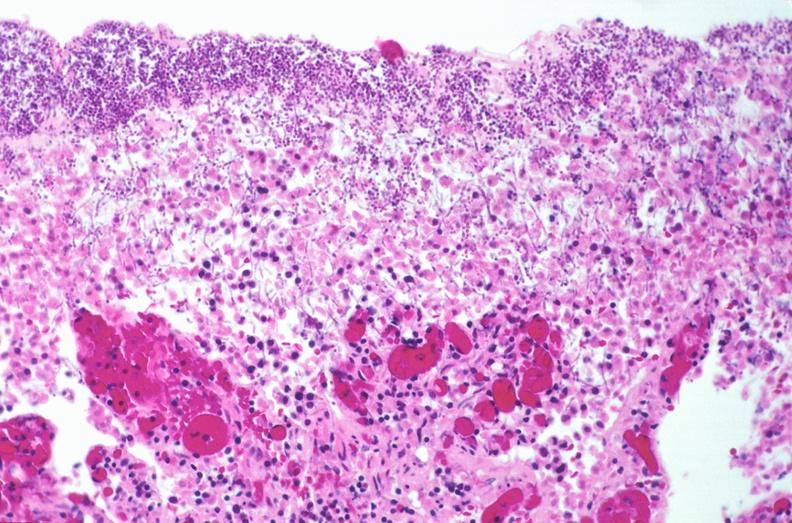does this image show duodenum, necrotizing enteritis with pseudomembrane, candida?
Answer the question using a single word or phrase. Yes 